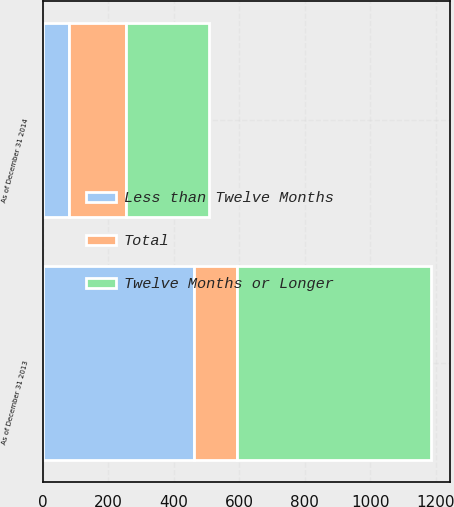<chart> <loc_0><loc_0><loc_500><loc_500><stacked_bar_chart><ecel><fcel>As of December 31 2014<fcel>As of December 31 2013<nl><fcel>Less than Twelve Months<fcel>80<fcel>462<nl><fcel>Total<fcel>173<fcel>130<nl><fcel>Twelve Months or Longer<fcel>253<fcel>592<nl></chart> 